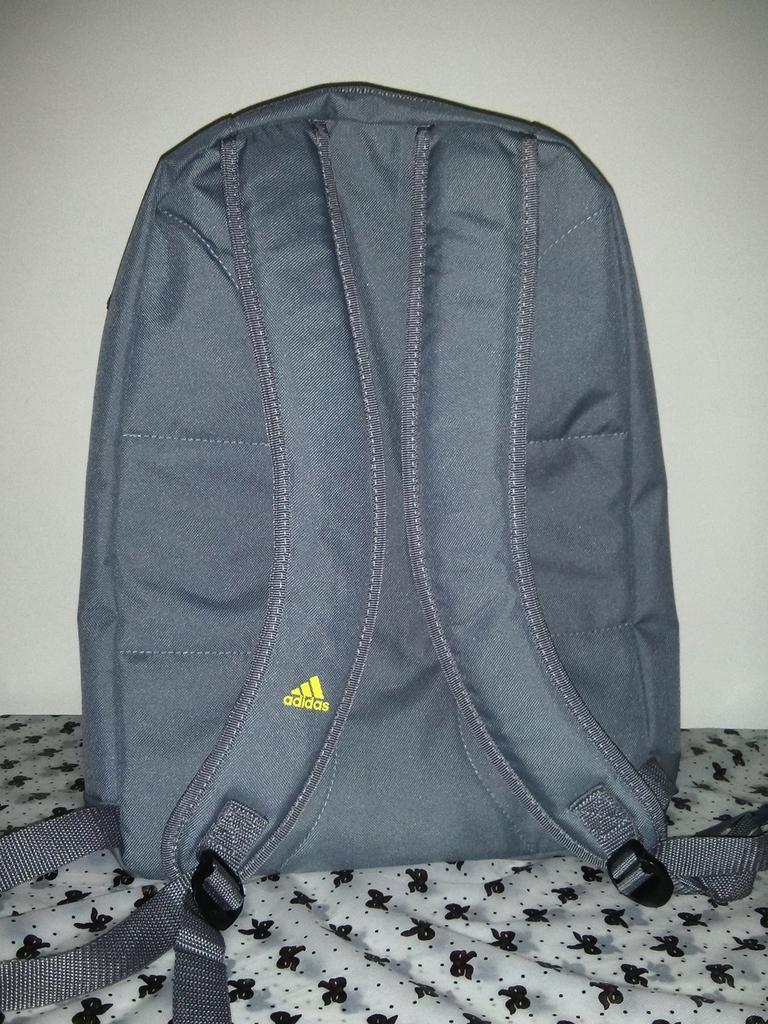What is the main object visible in the image? There is a backpack in the image. How does the backpack compare to a tree in terms of size in the image? The backpack cannot be compared to a tree in terms of size in the image, as there is no tree present in the image. 